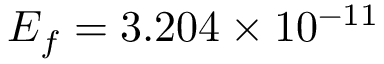<formula> <loc_0><loc_0><loc_500><loc_500>E _ { f } = 3 . 2 0 4 \times 1 0 ^ { - 1 1 }</formula> 